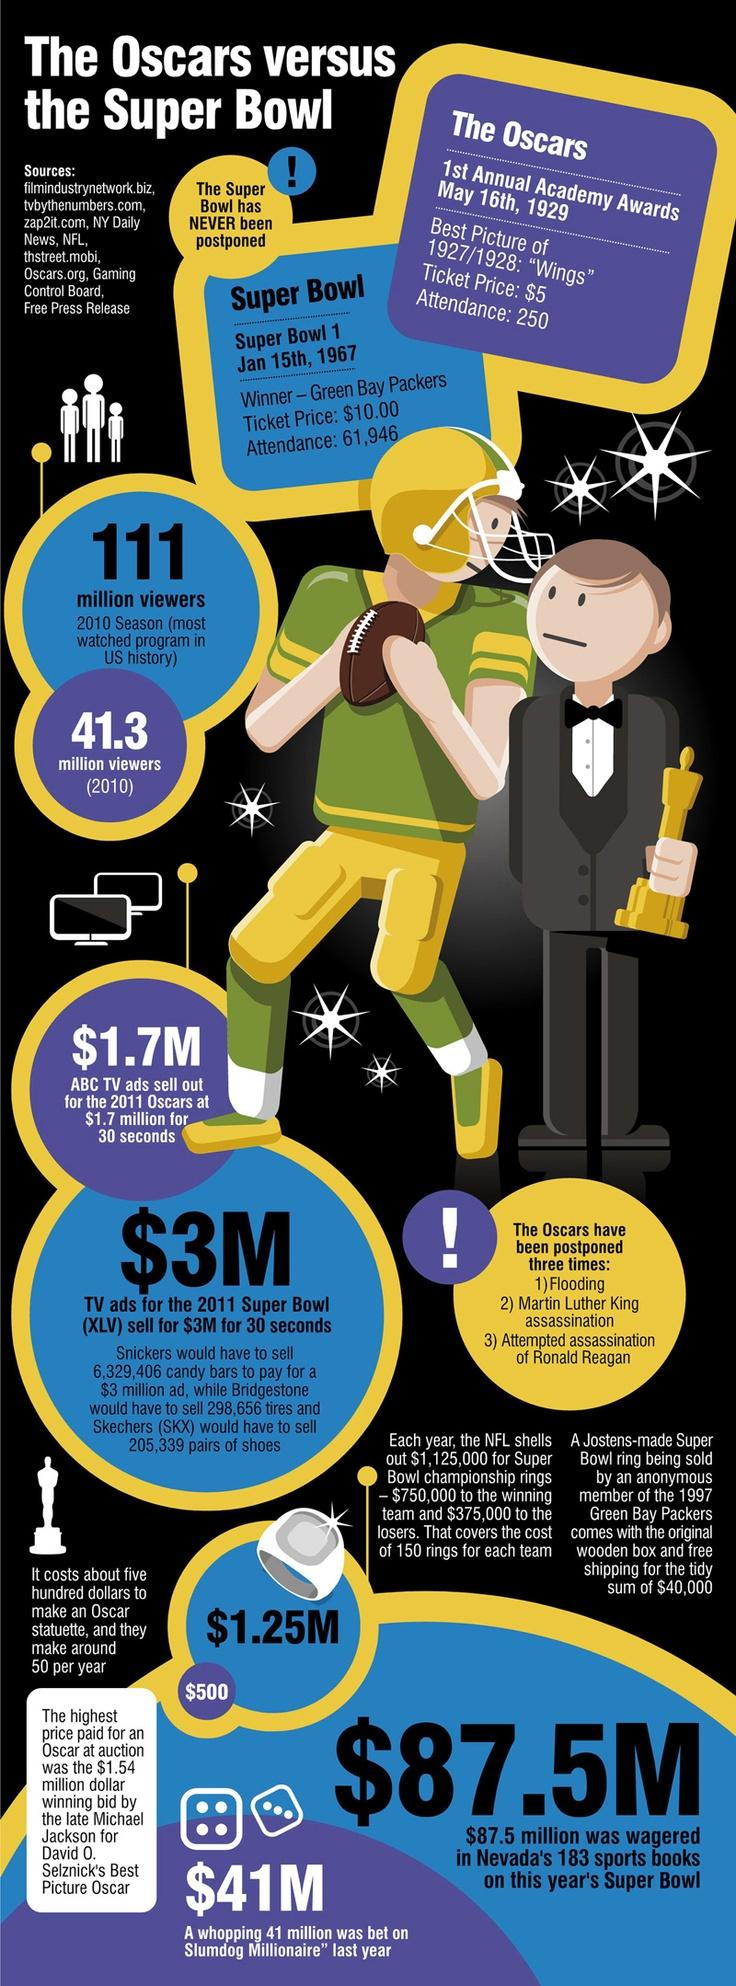Mention a couple of crucial points in this snapshot. In 1927/1928, the movie Wings won the Academy Award for Best Picture. The first annual Academy Awards was attended by 250 people. The Green Bay Packers won the first Super Bowl Championship title. The 2010 Super Bowl season in the US was watched by a grand total of 111 million viewers. 